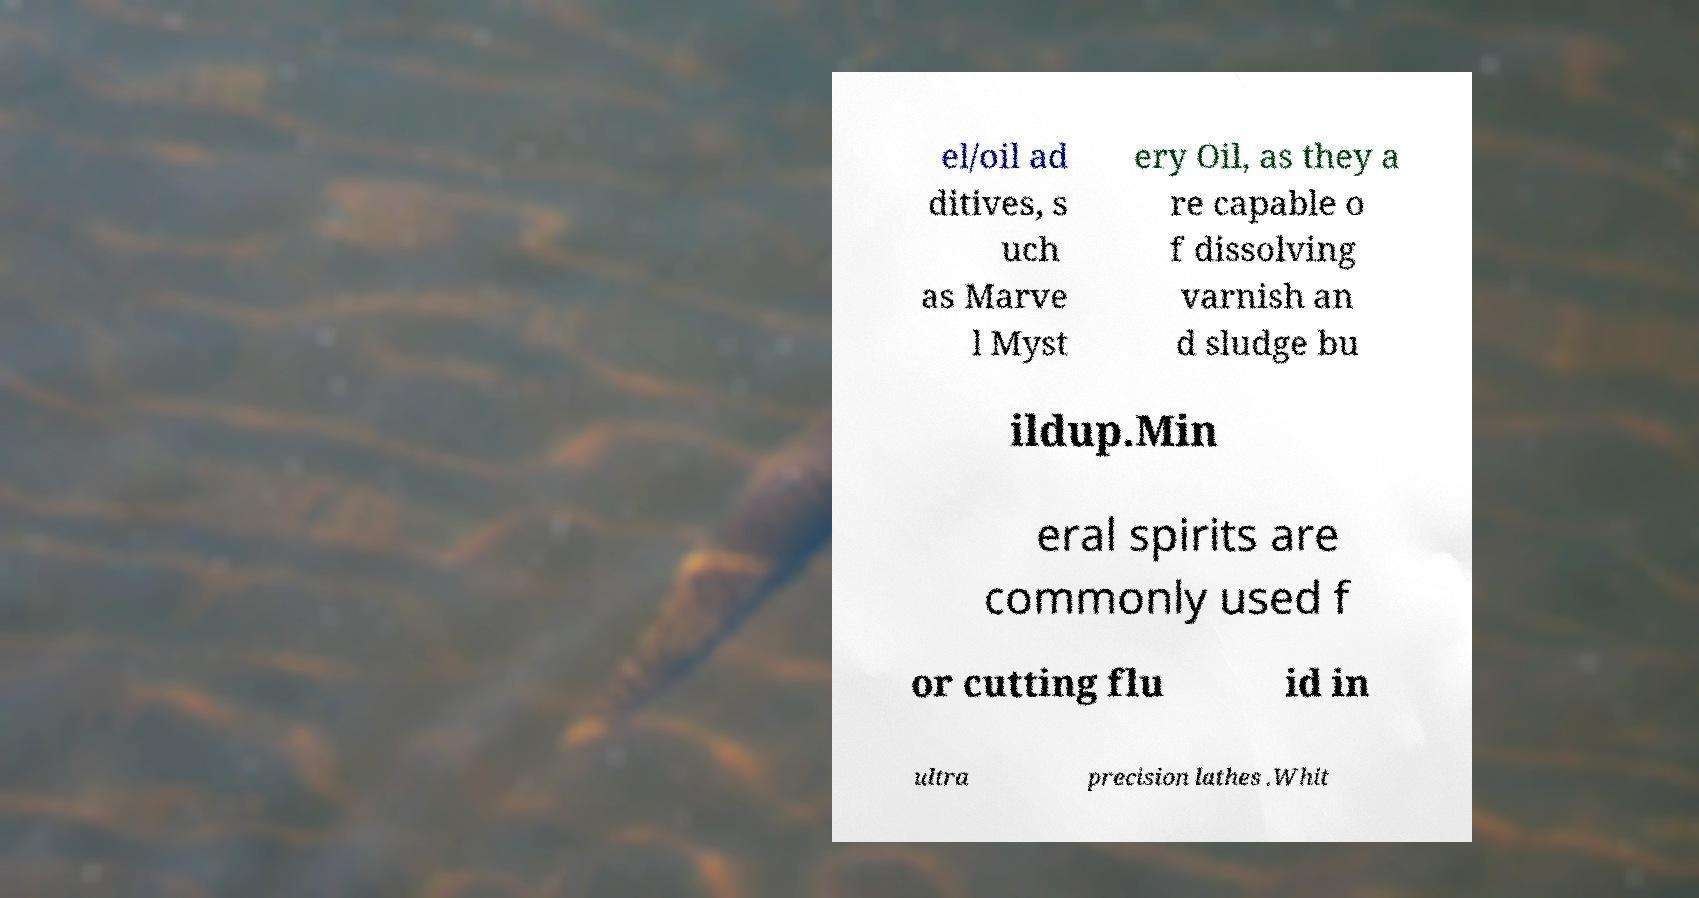Could you assist in decoding the text presented in this image and type it out clearly? el/oil ad ditives, s uch as Marve l Myst ery Oil, as they a re capable o f dissolving varnish an d sludge bu ildup.Min eral spirits are commonly used f or cutting flu id in ultra precision lathes .Whit 